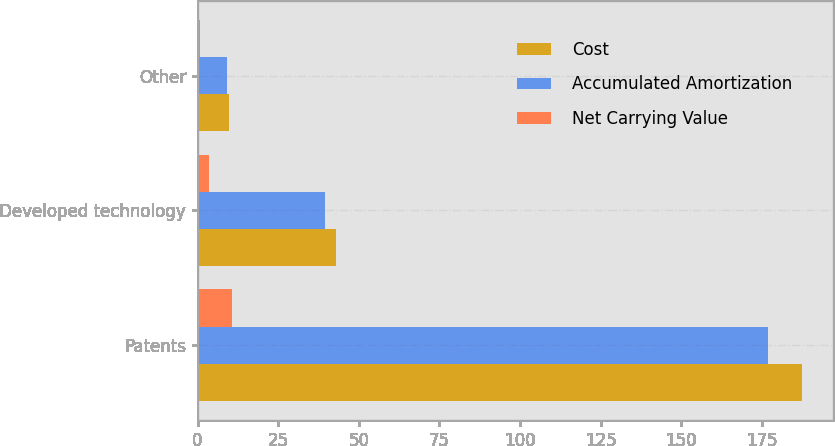Convert chart to OTSL. <chart><loc_0><loc_0><loc_500><loc_500><stacked_bar_chart><ecel><fcel>Patents<fcel>Developed technology<fcel>Other<nl><fcel>Cost<fcel>187.6<fcel>43<fcel>9.8<nl><fcel>Accumulated Amortization<fcel>177<fcel>39.6<fcel>9<nl><fcel>Net Carrying Value<fcel>10.6<fcel>3.4<fcel>0.8<nl></chart> 